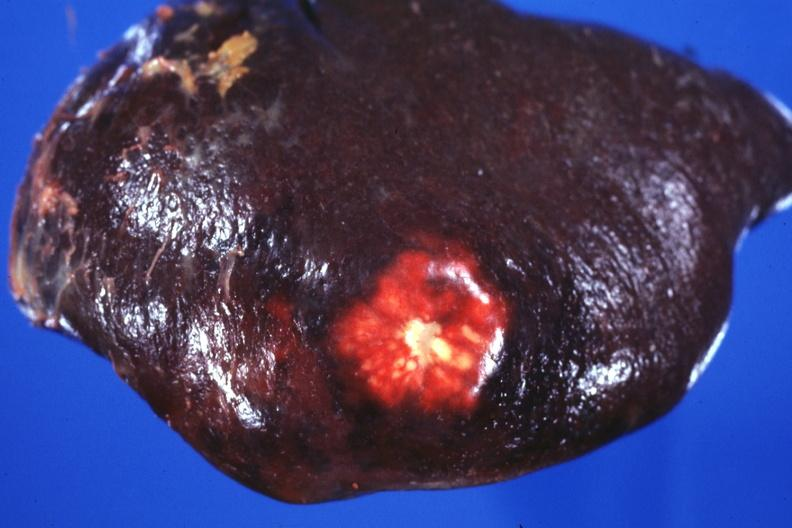s hematologic present?
Answer the question using a single word or phrase. Yes 